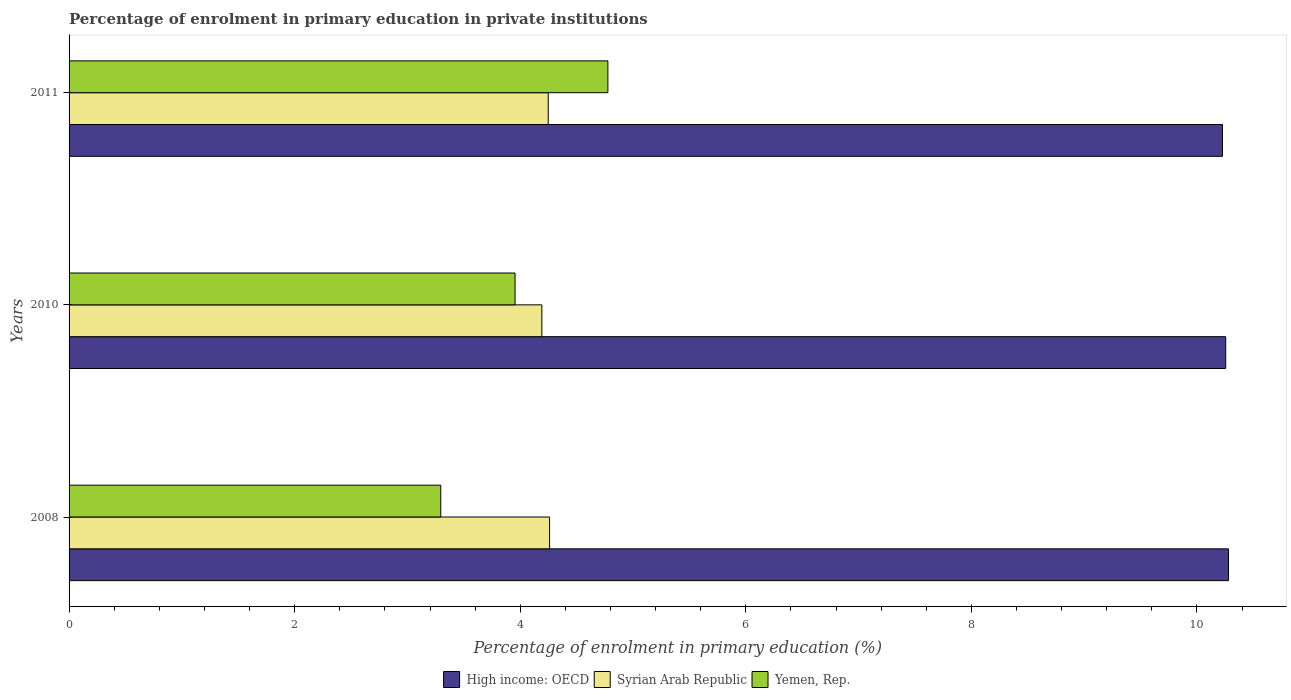How many different coloured bars are there?
Provide a succinct answer. 3. Are the number of bars per tick equal to the number of legend labels?
Give a very brief answer. Yes. How many bars are there on the 1st tick from the bottom?
Your response must be concise. 3. What is the percentage of enrolment in primary education in High income: OECD in 2008?
Ensure brevity in your answer.  10.28. Across all years, what is the maximum percentage of enrolment in primary education in Syrian Arab Republic?
Keep it short and to the point. 4.26. Across all years, what is the minimum percentage of enrolment in primary education in High income: OECD?
Provide a short and direct response. 10.23. In which year was the percentage of enrolment in primary education in High income: OECD maximum?
Keep it short and to the point. 2008. In which year was the percentage of enrolment in primary education in Yemen, Rep. minimum?
Your response must be concise. 2008. What is the total percentage of enrolment in primary education in High income: OECD in the graph?
Keep it short and to the point. 30.76. What is the difference between the percentage of enrolment in primary education in Yemen, Rep. in 2010 and that in 2011?
Keep it short and to the point. -0.82. What is the difference between the percentage of enrolment in primary education in High income: OECD in 2010 and the percentage of enrolment in primary education in Syrian Arab Republic in 2011?
Offer a terse response. 6.01. What is the average percentage of enrolment in primary education in High income: OECD per year?
Ensure brevity in your answer.  10.25. In the year 2010, what is the difference between the percentage of enrolment in primary education in Syrian Arab Republic and percentage of enrolment in primary education in High income: OECD?
Give a very brief answer. -6.06. In how many years, is the percentage of enrolment in primary education in Syrian Arab Republic greater than 0.8 %?
Keep it short and to the point. 3. What is the ratio of the percentage of enrolment in primary education in High income: OECD in 2008 to that in 2010?
Offer a very short reply. 1. What is the difference between the highest and the second highest percentage of enrolment in primary education in High income: OECD?
Ensure brevity in your answer.  0.03. What is the difference between the highest and the lowest percentage of enrolment in primary education in Yemen, Rep.?
Your answer should be compact. 1.48. Is the sum of the percentage of enrolment in primary education in Syrian Arab Republic in 2010 and 2011 greater than the maximum percentage of enrolment in primary education in High income: OECD across all years?
Ensure brevity in your answer.  No. What does the 1st bar from the top in 2008 represents?
Your response must be concise. Yemen, Rep. What does the 3rd bar from the bottom in 2008 represents?
Offer a terse response. Yemen, Rep. Is it the case that in every year, the sum of the percentage of enrolment in primary education in Yemen, Rep. and percentage of enrolment in primary education in Syrian Arab Republic is greater than the percentage of enrolment in primary education in High income: OECD?
Ensure brevity in your answer.  No. What is the difference between two consecutive major ticks on the X-axis?
Offer a very short reply. 2. Are the values on the major ticks of X-axis written in scientific E-notation?
Give a very brief answer. No. Where does the legend appear in the graph?
Provide a succinct answer. Bottom center. How many legend labels are there?
Offer a very short reply. 3. How are the legend labels stacked?
Provide a short and direct response. Horizontal. What is the title of the graph?
Make the answer very short. Percentage of enrolment in primary education in private institutions. Does "Low & middle income" appear as one of the legend labels in the graph?
Your response must be concise. No. What is the label or title of the X-axis?
Your response must be concise. Percentage of enrolment in primary education (%). What is the Percentage of enrolment in primary education (%) in High income: OECD in 2008?
Ensure brevity in your answer.  10.28. What is the Percentage of enrolment in primary education (%) of Syrian Arab Republic in 2008?
Offer a very short reply. 4.26. What is the Percentage of enrolment in primary education (%) of Yemen, Rep. in 2008?
Keep it short and to the point. 3.3. What is the Percentage of enrolment in primary education (%) of High income: OECD in 2010?
Provide a succinct answer. 10.25. What is the Percentage of enrolment in primary education (%) of Syrian Arab Republic in 2010?
Give a very brief answer. 4.19. What is the Percentage of enrolment in primary education (%) in Yemen, Rep. in 2010?
Your answer should be very brief. 3.95. What is the Percentage of enrolment in primary education (%) of High income: OECD in 2011?
Offer a terse response. 10.23. What is the Percentage of enrolment in primary education (%) of Syrian Arab Republic in 2011?
Offer a terse response. 4.25. What is the Percentage of enrolment in primary education (%) in Yemen, Rep. in 2011?
Your response must be concise. 4.78. Across all years, what is the maximum Percentage of enrolment in primary education (%) of High income: OECD?
Keep it short and to the point. 10.28. Across all years, what is the maximum Percentage of enrolment in primary education (%) of Syrian Arab Republic?
Make the answer very short. 4.26. Across all years, what is the maximum Percentage of enrolment in primary education (%) of Yemen, Rep.?
Your answer should be compact. 4.78. Across all years, what is the minimum Percentage of enrolment in primary education (%) of High income: OECD?
Your response must be concise. 10.23. Across all years, what is the minimum Percentage of enrolment in primary education (%) in Syrian Arab Republic?
Provide a short and direct response. 4.19. Across all years, what is the minimum Percentage of enrolment in primary education (%) of Yemen, Rep.?
Provide a short and direct response. 3.3. What is the total Percentage of enrolment in primary education (%) in High income: OECD in the graph?
Keep it short and to the point. 30.76. What is the total Percentage of enrolment in primary education (%) of Syrian Arab Republic in the graph?
Your answer should be compact. 12.7. What is the total Percentage of enrolment in primary education (%) in Yemen, Rep. in the graph?
Offer a terse response. 12.03. What is the difference between the Percentage of enrolment in primary education (%) in High income: OECD in 2008 and that in 2010?
Give a very brief answer. 0.03. What is the difference between the Percentage of enrolment in primary education (%) in Syrian Arab Republic in 2008 and that in 2010?
Make the answer very short. 0.07. What is the difference between the Percentage of enrolment in primary education (%) of Yemen, Rep. in 2008 and that in 2010?
Offer a very short reply. -0.66. What is the difference between the Percentage of enrolment in primary education (%) of High income: OECD in 2008 and that in 2011?
Your answer should be compact. 0.05. What is the difference between the Percentage of enrolment in primary education (%) in Syrian Arab Republic in 2008 and that in 2011?
Offer a terse response. 0.01. What is the difference between the Percentage of enrolment in primary education (%) in Yemen, Rep. in 2008 and that in 2011?
Give a very brief answer. -1.48. What is the difference between the Percentage of enrolment in primary education (%) in High income: OECD in 2010 and that in 2011?
Your answer should be compact. 0.03. What is the difference between the Percentage of enrolment in primary education (%) in Syrian Arab Republic in 2010 and that in 2011?
Offer a terse response. -0.06. What is the difference between the Percentage of enrolment in primary education (%) in Yemen, Rep. in 2010 and that in 2011?
Ensure brevity in your answer.  -0.82. What is the difference between the Percentage of enrolment in primary education (%) in High income: OECD in 2008 and the Percentage of enrolment in primary education (%) in Syrian Arab Republic in 2010?
Ensure brevity in your answer.  6.09. What is the difference between the Percentage of enrolment in primary education (%) of High income: OECD in 2008 and the Percentage of enrolment in primary education (%) of Yemen, Rep. in 2010?
Your answer should be very brief. 6.33. What is the difference between the Percentage of enrolment in primary education (%) in Syrian Arab Republic in 2008 and the Percentage of enrolment in primary education (%) in Yemen, Rep. in 2010?
Offer a terse response. 0.31. What is the difference between the Percentage of enrolment in primary education (%) in High income: OECD in 2008 and the Percentage of enrolment in primary education (%) in Syrian Arab Republic in 2011?
Offer a very short reply. 6.03. What is the difference between the Percentage of enrolment in primary education (%) of High income: OECD in 2008 and the Percentage of enrolment in primary education (%) of Yemen, Rep. in 2011?
Your response must be concise. 5.5. What is the difference between the Percentage of enrolment in primary education (%) of Syrian Arab Republic in 2008 and the Percentage of enrolment in primary education (%) of Yemen, Rep. in 2011?
Your answer should be very brief. -0.52. What is the difference between the Percentage of enrolment in primary education (%) in High income: OECD in 2010 and the Percentage of enrolment in primary education (%) in Syrian Arab Republic in 2011?
Give a very brief answer. 6.01. What is the difference between the Percentage of enrolment in primary education (%) of High income: OECD in 2010 and the Percentage of enrolment in primary education (%) of Yemen, Rep. in 2011?
Ensure brevity in your answer.  5.48. What is the difference between the Percentage of enrolment in primary education (%) in Syrian Arab Republic in 2010 and the Percentage of enrolment in primary education (%) in Yemen, Rep. in 2011?
Your answer should be compact. -0.59. What is the average Percentage of enrolment in primary education (%) of High income: OECD per year?
Provide a short and direct response. 10.25. What is the average Percentage of enrolment in primary education (%) in Syrian Arab Republic per year?
Give a very brief answer. 4.23. What is the average Percentage of enrolment in primary education (%) of Yemen, Rep. per year?
Offer a very short reply. 4.01. In the year 2008, what is the difference between the Percentage of enrolment in primary education (%) in High income: OECD and Percentage of enrolment in primary education (%) in Syrian Arab Republic?
Make the answer very short. 6.02. In the year 2008, what is the difference between the Percentage of enrolment in primary education (%) in High income: OECD and Percentage of enrolment in primary education (%) in Yemen, Rep.?
Provide a short and direct response. 6.98. In the year 2008, what is the difference between the Percentage of enrolment in primary education (%) in Syrian Arab Republic and Percentage of enrolment in primary education (%) in Yemen, Rep.?
Provide a succinct answer. 0.96. In the year 2010, what is the difference between the Percentage of enrolment in primary education (%) of High income: OECD and Percentage of enrolment in primary education (%) of Syrian Arab Republic?
Keep it short and to the point. 6.06. In the year 2010, what is the difference between the Percentage of enrolment in primary education (%) in High income: OECD and Percentage of enrolment in primary education (%) in Yemen, Rep.?
Your answer should be compact. 6.3. In the year 2010, what is the difference between the Percentage of enrolment in primary education (%) in Syrian Arab Republic and Percentage of enrolment in primary education (%) in Yemen, Rep.?
Keep it short and to the point. 0.24. In the year 2011, what is the difference between the Percentage of enrolment in primary education (%) in High income: OECD and Percentage of enrolment in primary education (%) in Syrian Arab Republic?
Provide a short and direct response. 5.98. In the year 2011, what is the difference between the Percentage of enrolment in primary education (%) in High income: OECD and Percentage of enrolment in primary education (%) in Yemen, Rep.?
Provide a short and direct response. 5.45. In the year 2011, what is the difference between the Percentage of enrolment in primary education (%) in Syrian Arab Republic and Percentage of enrolment in primary education (%) in Yemen, Rep.?
Ensure brevity in your answer.  -0.53. What is the ratio of the Percentage of enrolment in primary education (%) in Syrian Arab Republic in 2008 to that in 2010?
Provide a short and direct response. 1.02. What is the ratio of the Percentage of enrolment in primary education (%) of Yemen, Rep. in 2008 to that in 2010?
Make the answer very short. 0.83. What is the ratio of the Percentage of enrolment in primary education (%) in Syrian Arab Republic in 2008 to that in 2011?
Your answer should be very brief. 1. What is the ratio of the Percentage of enrolment in primary education (%) of Yemen, Rep. in 2008 to that in 2011?
Your answer should be compact. 0.69. What is the ratio of the Percentage of enrolment in primary education (%) of Syrian Arab Republic in 2010 to that in 2011?
Give a very brief answer. 0.99. What is the ratio of the Percentage of enrolment in primary education (%) of Yemen, Rep. in 2010 to that in 2011?
Your answer should be compact. 0.83. What is the difference between the highest and the second highest Percentage of enrolment in primary education (%) of High income: OECD?
Your response must be concise. 0.03. What is the difference between the highest and the second highest Percentage of enrolment in primary education (%) in Syrian Arab Republic?
Give a very brief answer. 0.01. What is the difference between the highest and the second highest Percentage of enrolment in primary education (%) of Yemen, Rep.?
Provide a succinct answer. 0.82. What is the difference between the highest and the lowest Percentage of enrolment in primary education (%) in High income: OECD?
Your response must be concise. 0.05. What is the difference between the highest and the lowest Percentage of enrolment in primary education (%) of Syrian Arab Republic?
Provide a succinct answer. 0.07. What is the difference between the highest and the lowest Percentage of enrolment in primary education (%) of Yemen, Rep.?
Offer a very short reply. 1.48. 